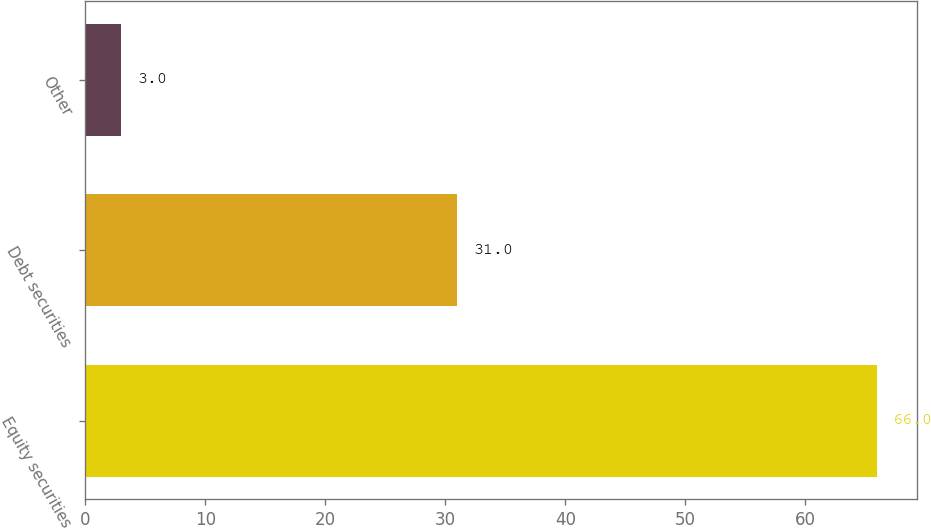Convert chart to OTSL. <chart><loc_0><loc_0><loc_500><loc_500><bar_chart><fcel>Equity securities<fcel>Debt securities<fcel>Other<nl><fcel>66<fcel>31<fcel>3<nl></chart> 